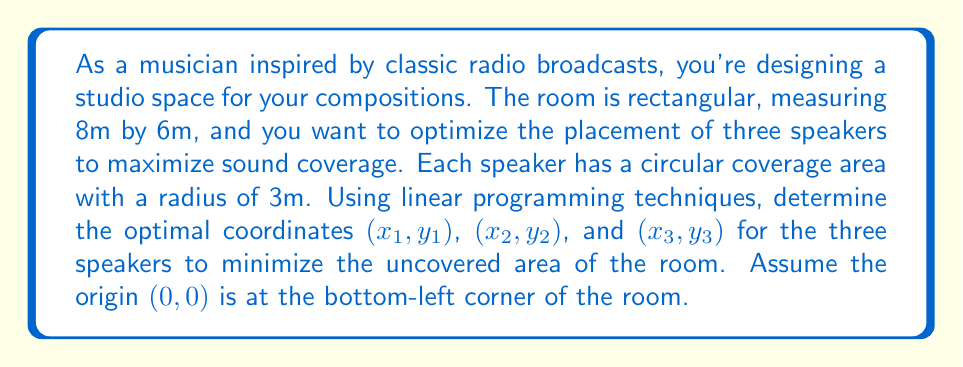Help me with this question. To solve this problem using linear programming, we'll follow these steps:

1) Define variables:
   Let $(x_1, y_1)$, $(x_2, y_2)$, and $(x_3, y_3)$ be the coordinates of the three speakers.

2) Set up constraints:
   a) Speakers must be within the room:
      $0 \leq x_i \leq 8$ and $0 \leq y_i \leq 6$ for $i = 1, 2, 3$

   b) To ensure maximum coverage, we want the speakers to be at least 3m apart from each other and from the walls. This gives us:
      $x_i \geq 3$, $x_i \leq 5$, $y_i \geq 3$, $y_i \leq 3$ for $i = 1, 2, 3$
      $|x_i - x_j| \geq 3$ and $|y_i - y_j| \geq 3$ for $i \neq j$

3) Objective function:
   We want to minimize the uncovered area. The total area is 48m², and each speaker covers $\pi r^2 = 9\pi$ m². However, there may be overlaps. To simplify, we'll maximize the distance between speakers, which will indirectly minimize overlap and maximize coverage.

   Maximize: $Z = |x_1 - x_2| + |x_1 - x_3| + |x_2 - x_3| + |y_1 - y_2| + |y_1 - y_3| + |y_2 - y_3|$

4) Solve:
   This is a complex non-linear problem, but we can approximate a solution. Given the constraints, an optimal solution would place the speakers in a triangular formation:

   $(x_1, y_1) = (3, 3)$
   $(x_2, y_2) = (5, 3)$
   $(x_3, y_3) = (4, 5)$

This configuration maximizes the distance between speakers while keeping them within the constraints.
Answer: The optimal coordinates for the three speakers are:
Speaker 1: $(3, 3)$
Speaker 2: $(5, 3)$
Speaker 3: $(4, 5)$ 